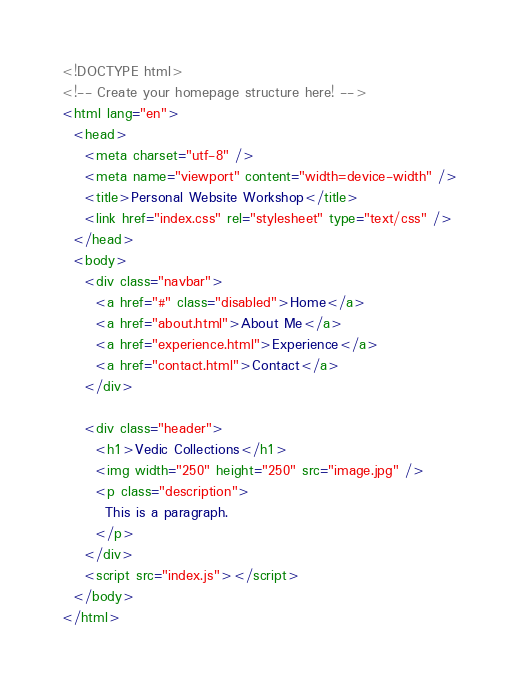Convert code to text. <code><loc_0><loc_0><loc_500><loc_500><_HTML_><!DOCTYPE html>
<!-- Create your homepage structure here! -->
<html lang="en">
  <head>
    <meta charset="utf-8" />
    <meta name="viewport" content="width=device-width" />
    <title>Personal Website Workshop</title>
    <link href="index.css" rel="stylesheet" type="text/css" />
  </head>
  <body>
    <div class="navbar">
      <a href="#" class="disabled">Home</a>
      <a href="about.html">About Me</a>
      <a href="experience.html">Experience</a>
      <a href="contact.html">Contact</a>
    </div>

    <div class="header">
      <h1>Vedic Collections</h1>
      <img width="250" height="250" src="image.jpg" />
      <p class="description">
        This is a paragraph.
      </p>
    </div>
    <script src="index.js"></script>
  </body>
</html>
</code> 